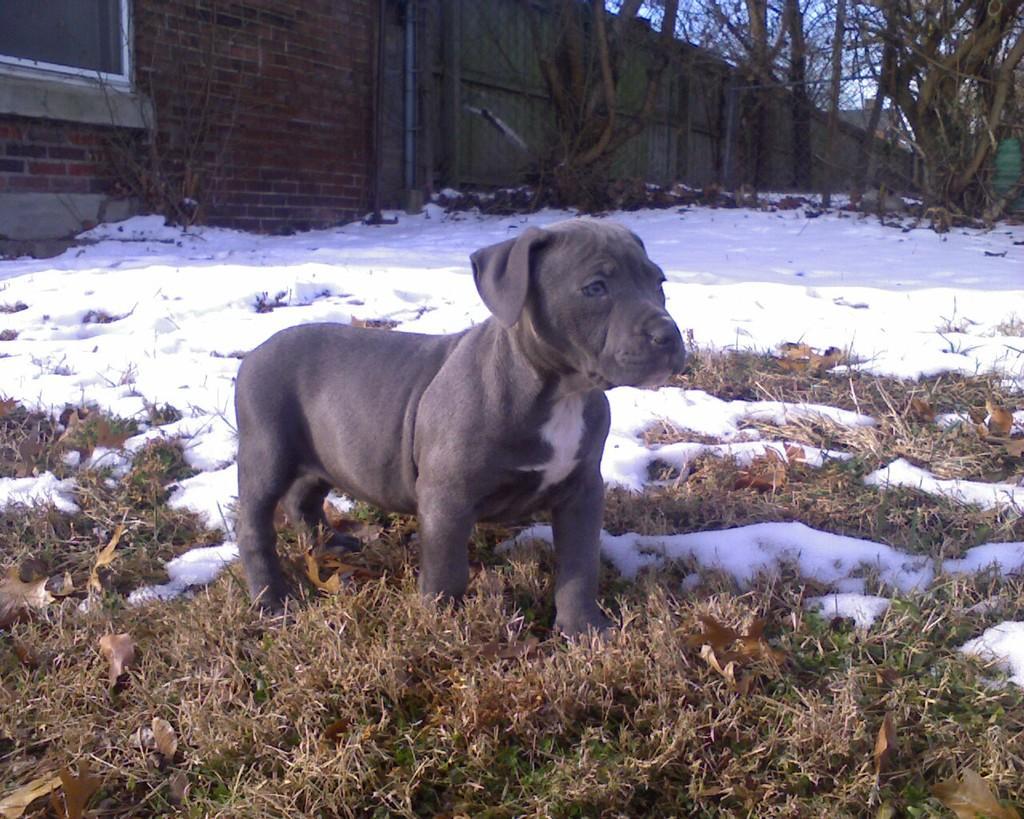In one or two sentences, can you explain what this image depicts? In the picture we can see dog which is black in color, there is snow and in the background of the picture there are some houses, trees and clear sky. 